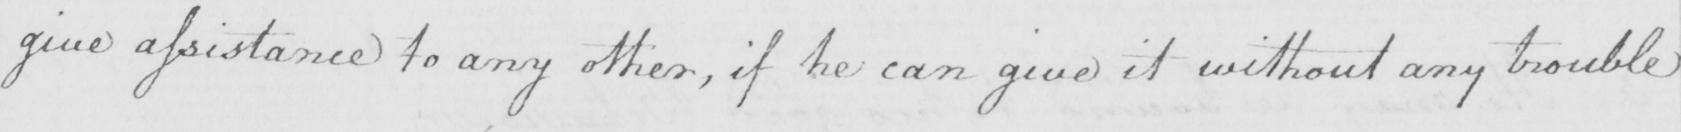Can you tell me what this handwritten text says? give assistance to any other , if he can give it without any trouble 